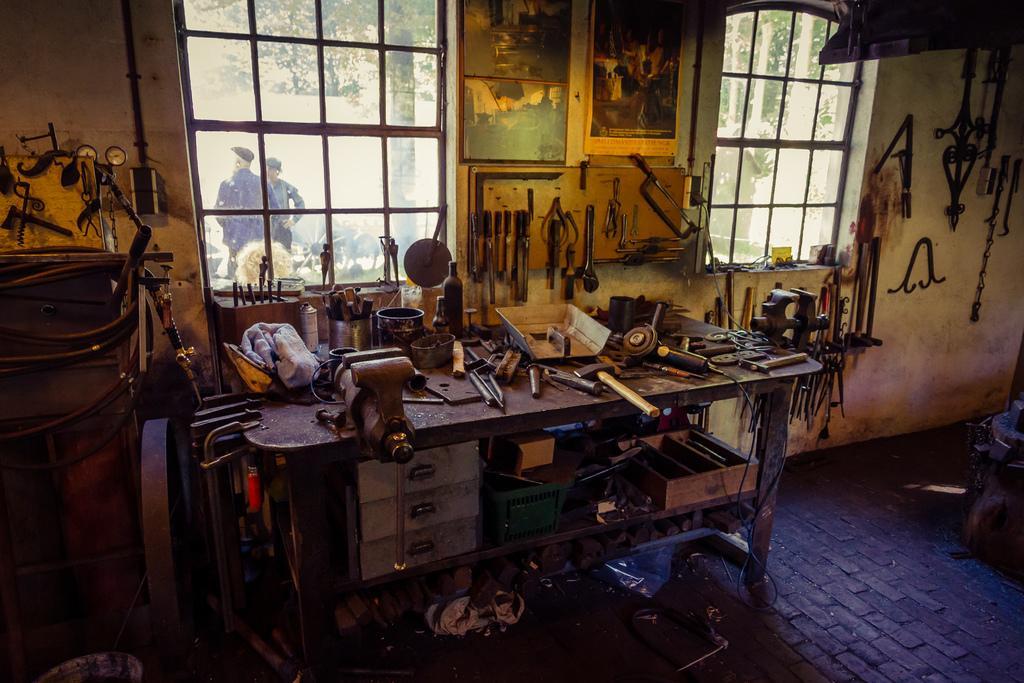Could you give a brief overview of what you see in this image? In this picture there is a table in the center of the image and there are tools on the table and hanged on the walls and there are windows at the top side of the image, there are trees and men outside of the windows. 